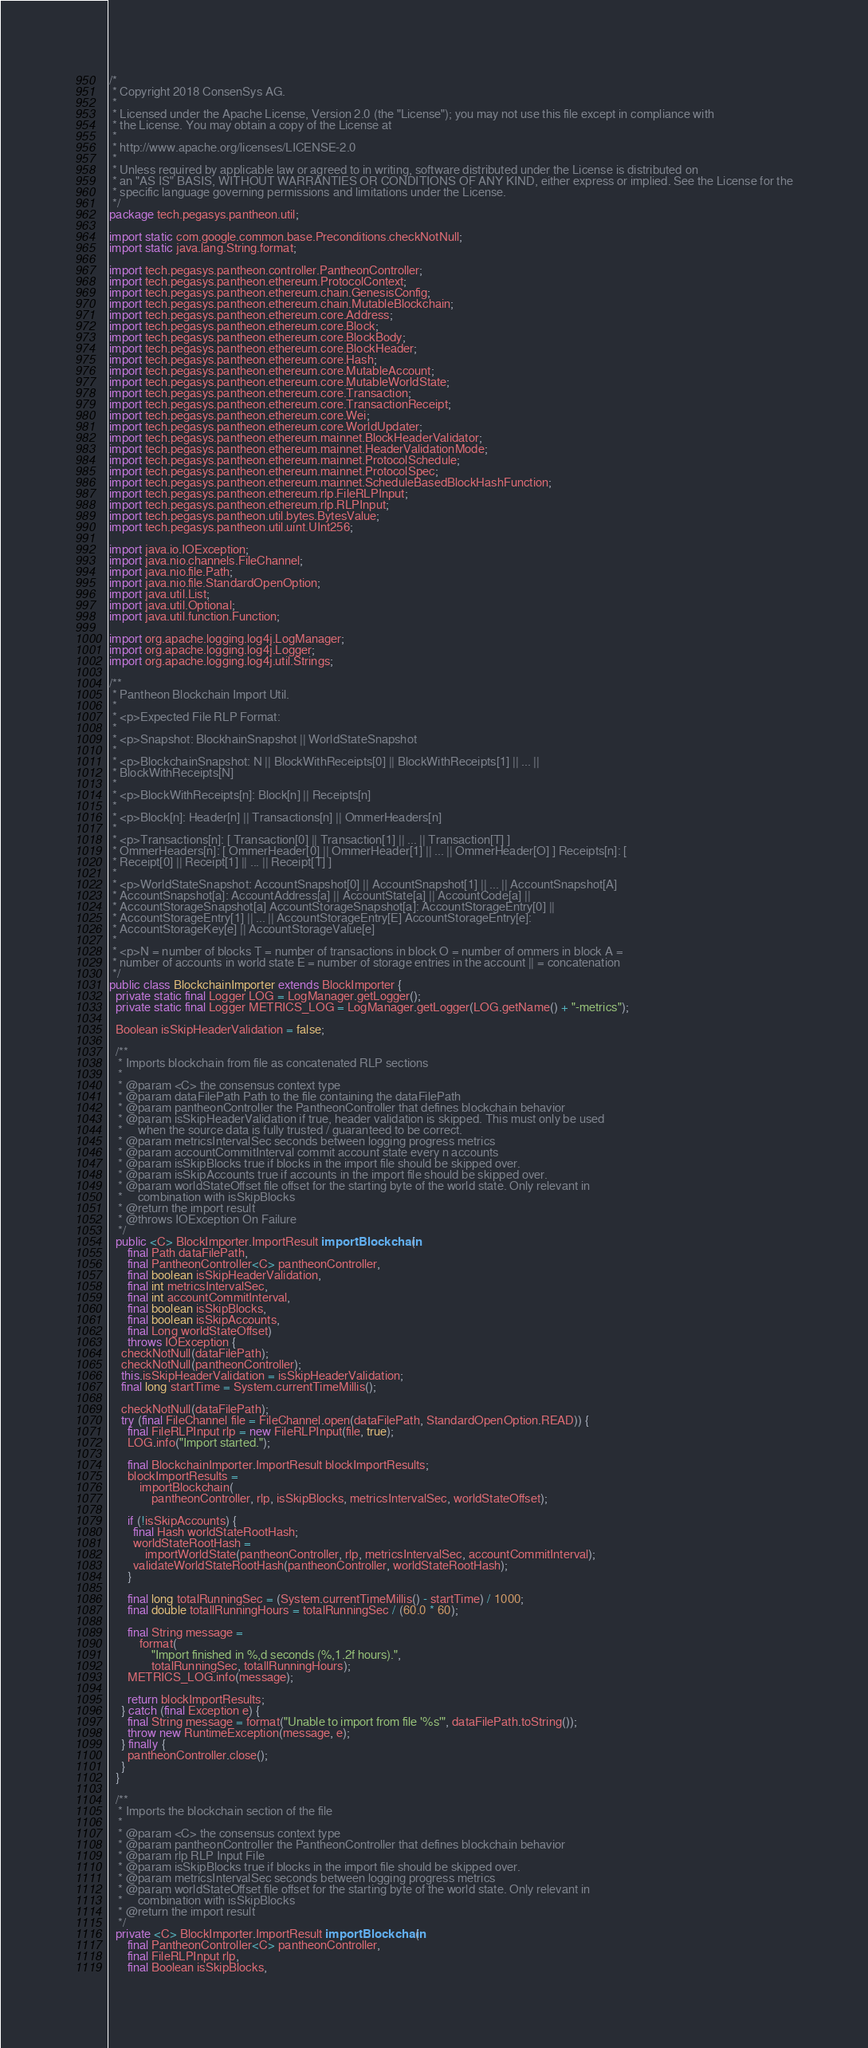Convert code to text. <code><loc_0><loc_0><loc_500><loc_500><_Java_>/*
 * Copyright 2018 ConsenSys AG.
 *
 * Licensed under the Apache License, Version 2.0 (the "License"); you may not use this file except in compliance with
 * the License. You may obtain a copy of the License at
 *
 * http://www.apache.org/licenses/LICENSE-2.0
 *
 * Unless required by applicable law or agreed to in writing, software distributed under the License is distributed on
 * an "AS IS" BASIS, WITHOUT WARRANTIES OR CONDITIONS OF ANY KIND, either express or implied. See the License for the
 * specific language governing permissions and limitations under the License.
 */
package tech.pegasys.pantheon.util;

import static com.google.common.base.Preconditions.checkNotNull;
import static java.lang.String.format;

import tech.pegasys.pantheon.controller.PantheonController;
import tech.pegasys.pantheon.ethereum.ProtocolContext;
import tech.pegasys.pantheon.ethereum.chain.GenesisConfig;
import tech.pegasys.pantheon.ethereum.chain.MutableBlockchain;
import tech.pegasys.pantheon.ethereum.core.Address;
import tech.pegasys.pantheon.ethereum.core.Block;
import tech.pegasys.pantheon.ethereum.core.BlockBody;
import tech.pegasys.pantheon.ethereum.core.BlockHeader;
import tech.pegasys.pantheon.ethereum.core.Hash;
import tech.pegasys.pantheon.ethereum.core.MutableAccount;
import tech.pegasys.pantheon.ethereum.core.MutableWorldState;
import tech.pegasys.pantheon.ethereum.core.Transaction;
import tech.pegasys.pantheon.ethereum.core.TransactionReceipt;
import tech.pegasys.pantheon.ethereum.core.Wei;
import tech.pegasys.pantheon.ethereum.core.WorldUpdater;
import tech.pegasys.pantheon.ethereum.mainnet.BlockHeaderValidator;
import tech.pegasys.pantheon.ethereum.mainnet.HeaderValidationMode;
import tech.pegasys.pantheon.ethereum.mainnet.ProtocolSchedule;
import tech.pegasys.pantheon.ethereum.mainnet.ProtocolSpec;
import tech.pegasys.pantheon.ethereum.mainnet.ScheduleBasedBlockHashFunction;
import tech.pegasys.pantheon.ethereum.rlp.FileRLPInput;
import tech.pegasys.pantheon.ethereum.rlp.RLPInput;
import tech.pegasys.pantheon.util.bytes.BytesValue;
import tech.pegasys.pantheon.util.uint.UInt256;

import java.io.IOException;
import java.nio.channels.FileChannel;
import java.nio.file.Path;
import java.nio.file.StandardOpenOption;
import java.util.List;
import java.util.Optional;
import java.util.function.Function;

import org.apache.logging.log4j.LogManager;
import org.apache.logging.log4j.Logger;
import org.apache.logging.log4j.util.Strings;

/**
 * Pantheon Blockchain Import Util.
 *
 * <p>Expected File RLP Format:
 *
 * <p>Snapshot: BlockhainSnapshot || WorldStateSnapshot
 *
 * <p>BlockchainSnapshot: N || BlockWithReceipts[0] || BlockWithReceipts[1] || ... ||
 * BlockWithReceipts[N]
 *
 * <p>BlockWithReceipts[n]: Block[n] || Receipts[n]
 *
 * <p>Block[n]: Header[n] || Transactions[n] || OmmerHeaders[n]
 *
 * <p>Transactions[n]: [ Transaction[0] || Transaction[1] || ... || Transaction[T] ]
 * OmmerHeaders[n]: [ OmmerHeader[0] || OmmerHeader[1] || ... || OmmerHeader[O] ] Receipts[n]: [
 * Receipt[0] || Receipt[1] || ... || Receipt[T] ]
 *
 * <p>WorldStateSnapshot: AccountSnapshot[0] || AccountSnapshot[1] || ... || AccountSnapshot[A]
 * AccountSnapshot[a]: AccountAddress[a] || AccountState[a] || AccountCode[a] ||
 * AccountStorageSnapshot[a] AccountStorageSnapshot[a]: AccountStorageEntry[0] ||
 * AccountStorageEntry[1] || ... || AccountStorageEntry[E] AccountStorageEntry[e]:
 * AccountStorageKey[e] || AccountStorageValue[e]
 *
 * <p>N = number of blocks T = number of transactions in block O = number of ommers in block A =
 * number of accounts in world state E = number of storage entries in the account || = concatenation
 */
public class BlockchainImporter extends BlockImporter {
  private static final Logger LOG = LogManager.getLogger();
  private static final Logger METRICS_LOG = LogManager.getLogger(LOG.getName() + "-metrics");

  Boolean isSkipHeaderValidation = false;

  /**
   * Imports blockchain from file as concatenated RLP sections
   *
   * @param <C> the consensus context type
   * @param dataFilePath Path to the file containing the dataFilePath
   * @param pantheonController the PantheonController that defines blockchain behavior
   * @param isSkipHeaderValidation if true, header validation is skipped. This must only be used
   *     when the source data is fully trusted / guaranteed to be correct.
   * @param metricsIntervalSec seconds between logging progress metrics
   * @param accountCommitInterval commit account state every n accounts
   * @param isSkipBlocks true if blocks in the import file should be skipped over.
   * @param isSkipAccounts true if accounts in the import file should be skipped over.
   * @param worldStateOffset file offset for the starting byte of the world state. Only relevant in
   *     combination with isSkipBlocks
   * @return the import result
   * @throws IOException On Failure
   */
  public <C> BlockImporter.ImportResult importBlockchain(
      final Path dataFilePath,
      final PantheonController<C> pantheonController,
      final boolean isSkipHeaderValidation,
      final int metricsIntervalSec,
      final int accountCommitInterval,
      final boolean isSkipBlocks,
      final boolean isSkipAccounts,
      final Long worldStateOffset)
      throws IOException {
    checkNotNull(dataFilePath);
    checkNotNull(pantheonController);
    this.isSkipHeaderValidation = isSkipHeaderValidation;
    final long startTime = System.currentTimeMillis();

    checkNotNull(dataFilePath);
    try (final FileChannel file = FileChannel.open(dataFilePath, StandardOpenOption.READ)) {
      final FileRLPInput rlp = new FileRLPInput(file, true);
      LOG.info("Import started.");

      final BlockchainImporter.ImportResult blockImportResults;
      blockImportResults =
          importBlockchain(
              pantheonController, rlp, isSkipBlocks, metricsIntervalSec, worldStateOffset);

      if (!isSkipAccounts) {
        final Hash worldStateRootHash;
        worldStateRootHash =
            importWorldState(pantheonController, rlp, metricsIntervalSec, accountCommitInterval);
        validateWorldStateRootHash(pantheonController, worldStateRootHash);
      }

      final long totalRunningSec = (System.currentTimeMillis() - startTime) / 1000;
      final double totallRunningHours = totalRunningSec / (60.0 * 60);

      final String message =
          format(
              "Import finished in %,d seconds (%,1.2f hours).",
              totalRunningSec, totallRunningHours);
      METRICS_LOG.info(message);

      return blockImportResults;
    } catch (final Exception e) {
      final String message = format("Unable to import from file '%s'", dataFilePath.toString());
      throw new RuntimeException(message, e);
    } finally {
      pantheonController.close();
    }
  }

  /**
   * Imports the blockchain section of the file
   *
   * @param <C> the consensus context type
   * @param pantheonController the PantheonController that defines blockchain behavior
   * @param rlp RLP Input File
   * @param isSkipBlocks true if blocks in the import file should be skipped over.
   * @param metricsIntervalSec seconds between logging progress metrics
   * @param worldStateOffset file offset for the starting byte of the world state. Only relevant in
   *     combination with isSkipBlocks
   * @return the import result
   */
  private <C> BlockImporter.ImportResult importBlockchain(
      final PantheonController<C> pantheonController,
      final FileRLPInput rlp,
      final Boolean isSkipBlocks,</code> 